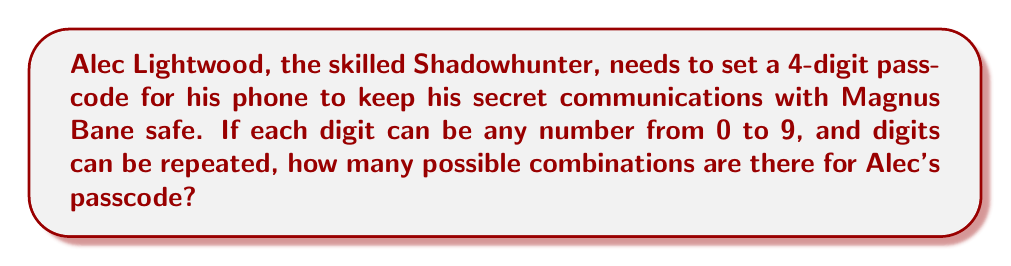Help me with this question. To solve this problem, we need to use the fundamental counting principle from combinatorics. Here's how we approach it:

1. For each digit in the passcode, Alec has 10 choices (0 through 9).
2. The passcode is 4 digits long.
3. Each digit's choice is independent of the others, and digits can be repeated.

Therefore, we can calculate the total number of possible combinations as follows:

$$ \text{Total combinations} = 10 \times 10 \times 10 \times 10 $$

This is because:
- For the first digit, Alec has 10 choices
- For the second digit, he again has 10 choices
- For the third digit, once more 10 choices
- And for the fourth digit, 10 choices again

We can express this more concisely as:

$$ \text{Total combinations} = 10^4 $$

Calculating this:

$$ 10^4 = 10,000 $$

Thus, there are 10,000 possible combinations for Alec's 4-digit passcode.
Answer: $10,000$ 